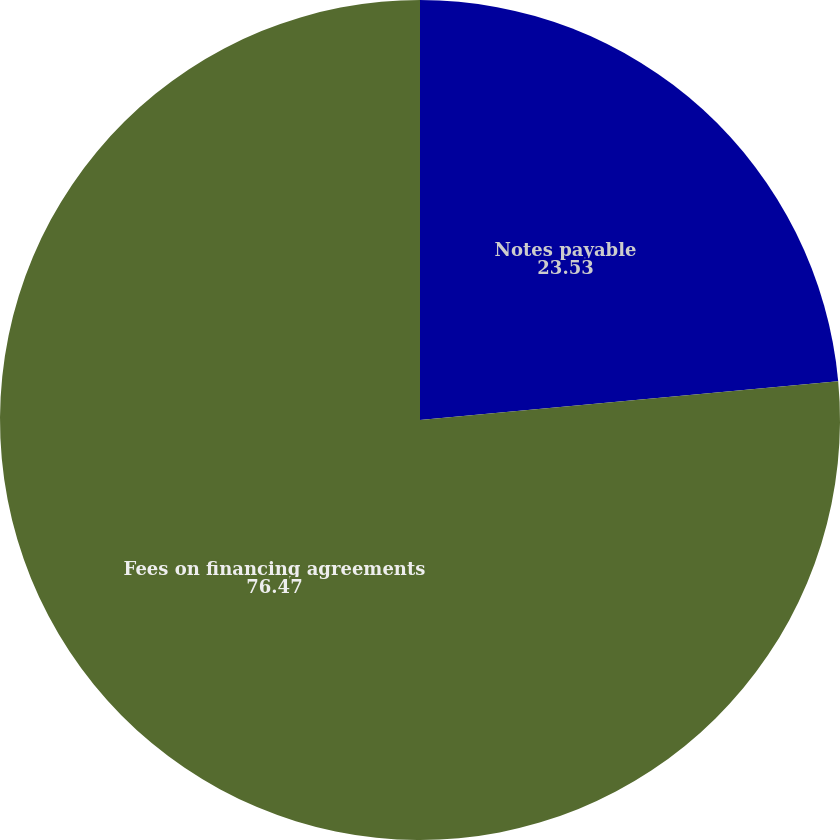<chart> <loc_0><loc_0><loc_500><loc_500><pie_chart><fcel>Notes payable<fcel>Fees on financing agreements<nl><fcel>23.53%<fcel>76.47%<nl></chart> 